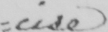Can you tell me what this handwritten text says? =cise 